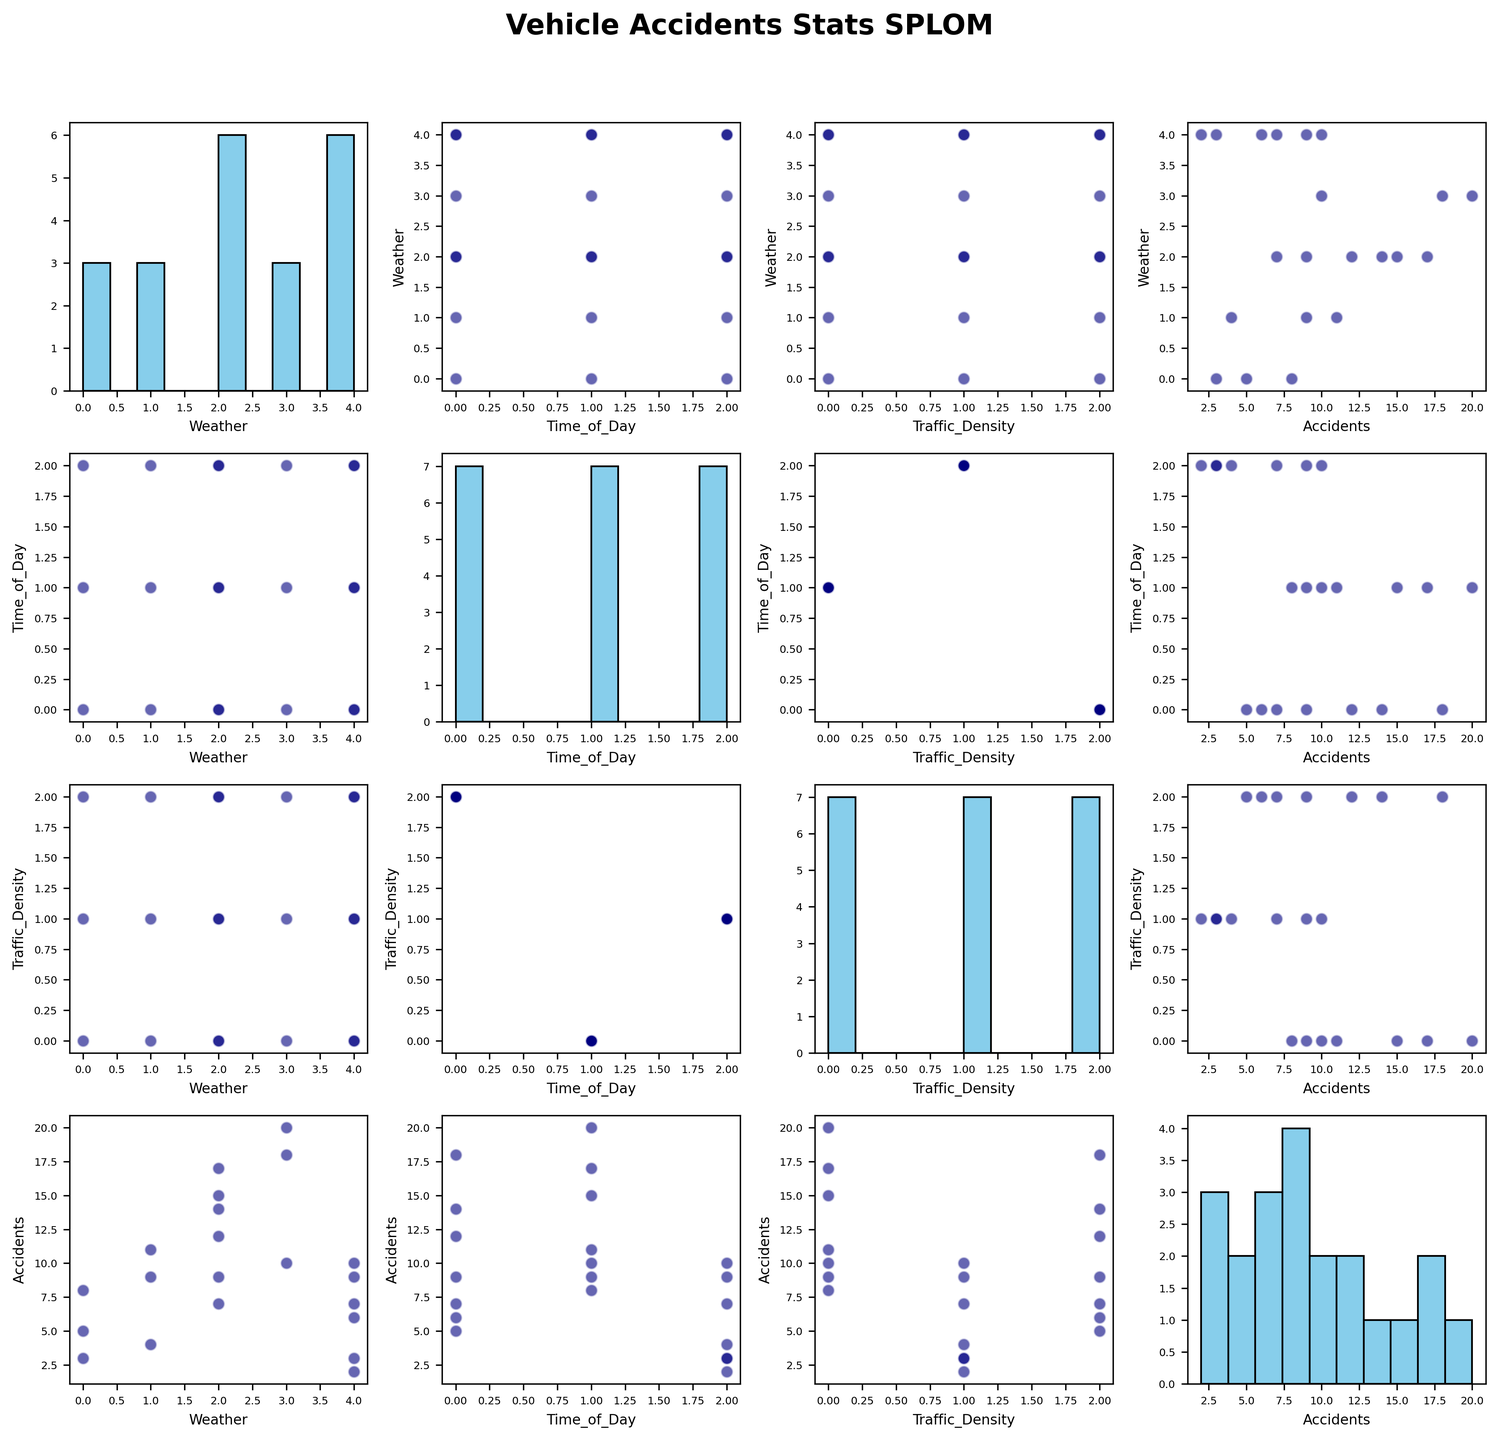What is the title of the figure? The title of the figure is written at the top and usually provides a brief idea of what the figure represents.
Answer: Vehicle Accidents Stats SPLOM How many variables are compared in the scatter plot matrix? The scatter plot matrix compares multiple variables which are indicated by the axes labels in the plots. You can count the unique variables based on these labels.
Answer: 4 What is the relationship between Weather and Accidents? To identify the relationship, look at the scatter plot that has Weather on one axis and Accidents on the other. Look for any visible trend or correlation, like a clear upward or downward direction among the scattered points.
Answer: Higher accidents in Rainy and Snowy conditions Which time of day has the highest number of accidents? Look at the scatter plots or histogram where Time_of_Day is plotted against Accidents. Identify the time of day that consistently has the highest values in accidents.
Answer: Morning Which pair of variables shows the strongest correlation, and what is the nature of this correlation? Look at all the scatter plots focusing on the clustering and direction of data points. The pair with the most linear-looking scatter plot indicates a strong correlation, either positive or negative.
Answer: Morning time and high traffic density show a strong positive correlation with accidents During which weather condition do accidents peak, according to the scatter plots or histograms? Check the scatter plots or histograms where Weather is plotted against Accidents and identify the weather condition that has the highest number of accidents.
Answer: Snowy Is there any trend or pattern visible for accidents over different Traffic Density levels? Observe the scatter plots that compare Traffic Density with Accidents. Look for any recognizable pattern like an upward or downward slope or clustering of data points.
Answer: Higher Traffic Density correlates with more accidents Among the scatter plots, which plot shows a linear relationship between two variables? Look closely at all scatter plots to see which one has points that form a straight line, indicating a linear relationship.
Answer: Traffic Density vs. Accidents Which weather condition results in the least number of accidents? Look at the scatter plots or histograms where Weather is plotted against Accidents and identify the weather condition with the lowest number of accidents.
Answer: Sunny 